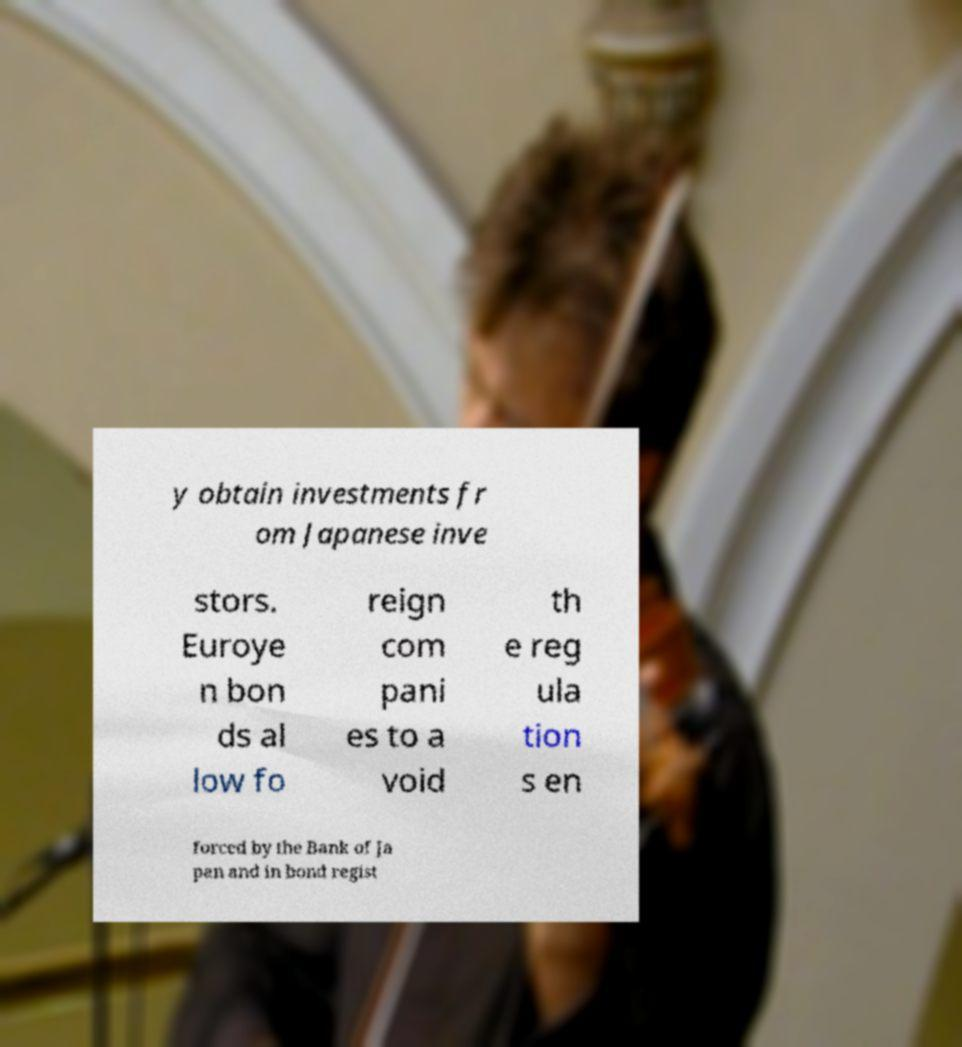For documentation purposes, I need the text within this image transcribed. Could you provide that? y obtain investments fr om Japanese inve stors. Euroye n bon ds al low fo reign com pani es to a void th e reg ula tion s en forced by the Bank of Ja pan and in bond regist 